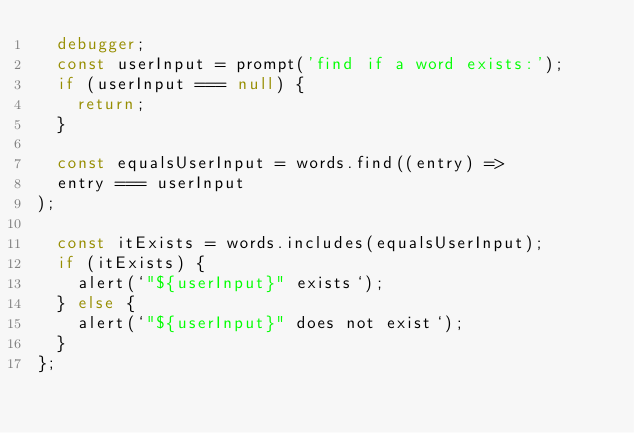Convert code to text. <code><loc_0><loc_0><loc_500><loc_500><_JavaScript_>  debugger;
  const userInput = prompt('find if a word exists:');
  if (userInput === null) {
    return;
  }

  const equalsUserInput = words.find((entry) => 
  entry === userInput
);

  const itExists = words.includes(equalsUserInput);
  if (itExists) {
    alert(`"${userInput}" exists`);
  } else {
    alert(`"${userInput}" does not exist`);
  }
};
</code> 